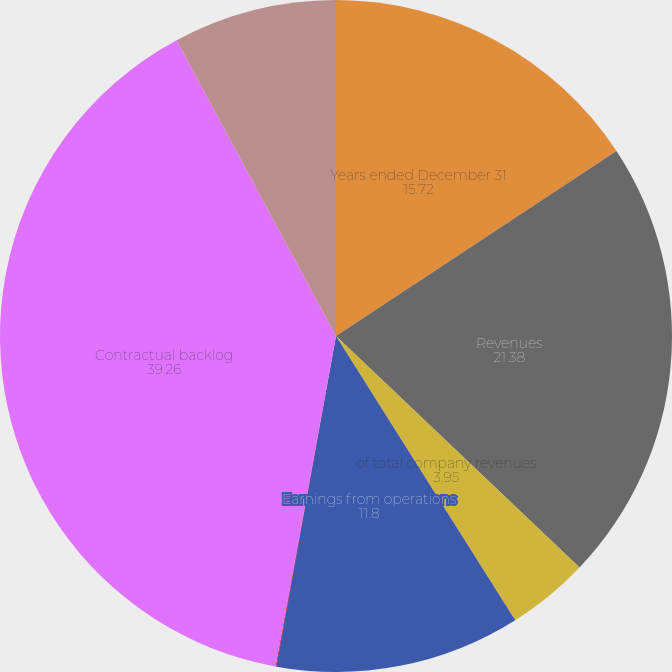<chart> <loc_0><loc_0><loc_500><loc_500><pie_chart><fcel>Years ended December 31<fcel>Revenues<fcel>of total company revenues<fcel>Earnings from operations<fcel>Operating margins<fcel>Contractual backlog<fcel>Unobligated backlog<nl><fcel>15.72%<fcel>21.38%<fcel>3.95%<fcel>11.8%<fcel>0.03%<fcel>39.26%<fcel>7.87%<nl></chart> 